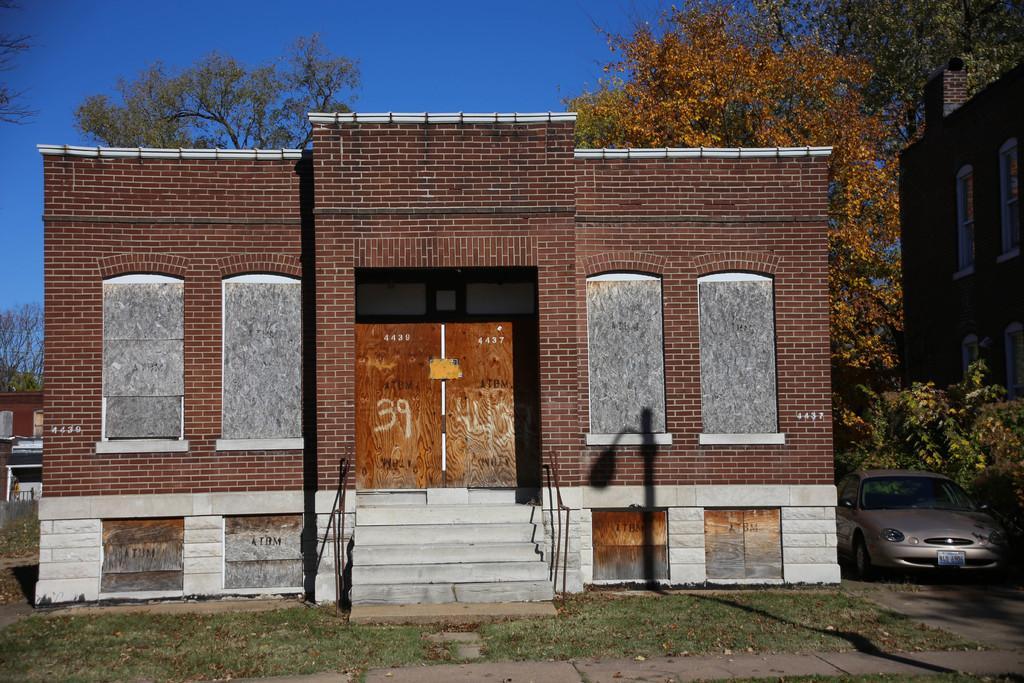How would you summarize this image in a sentence or two? In this image we can see a building with windows, steps, railings and doors. In front of the building there is grass. On the right side there is car, trees and other building with windows. In the background there is sky, trees, and building. 